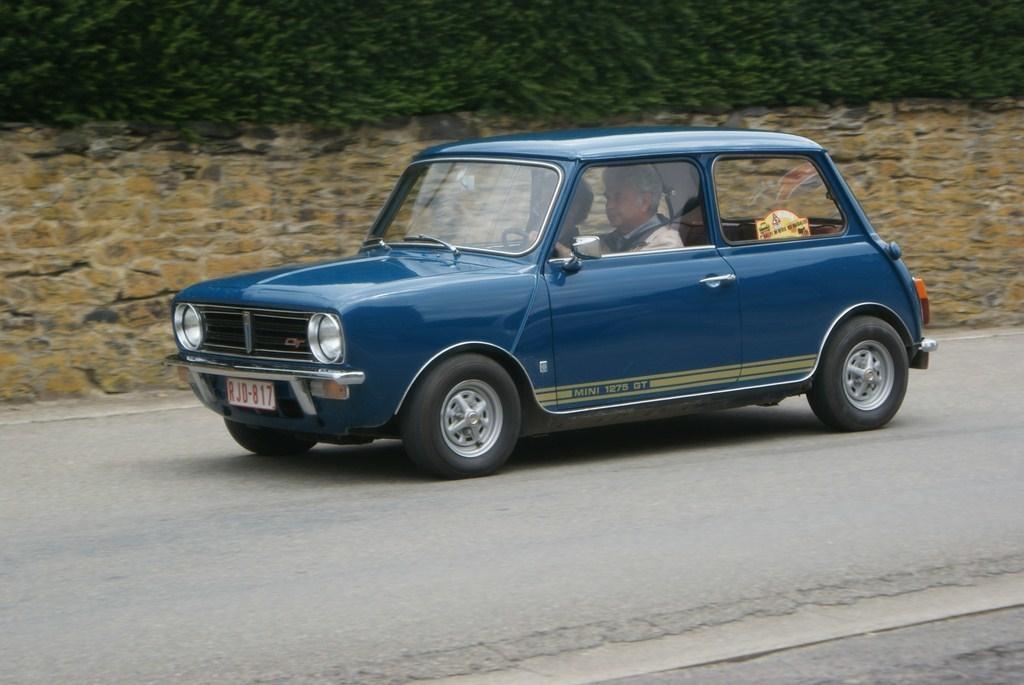In one or two sentences, can you explain what this image depicts? This picture is clicked outside. In the center there is a blue color car seems to be running on the road and we can see the two persons riding the car. In the background we can see the ground and the green object seems to be the grass. 